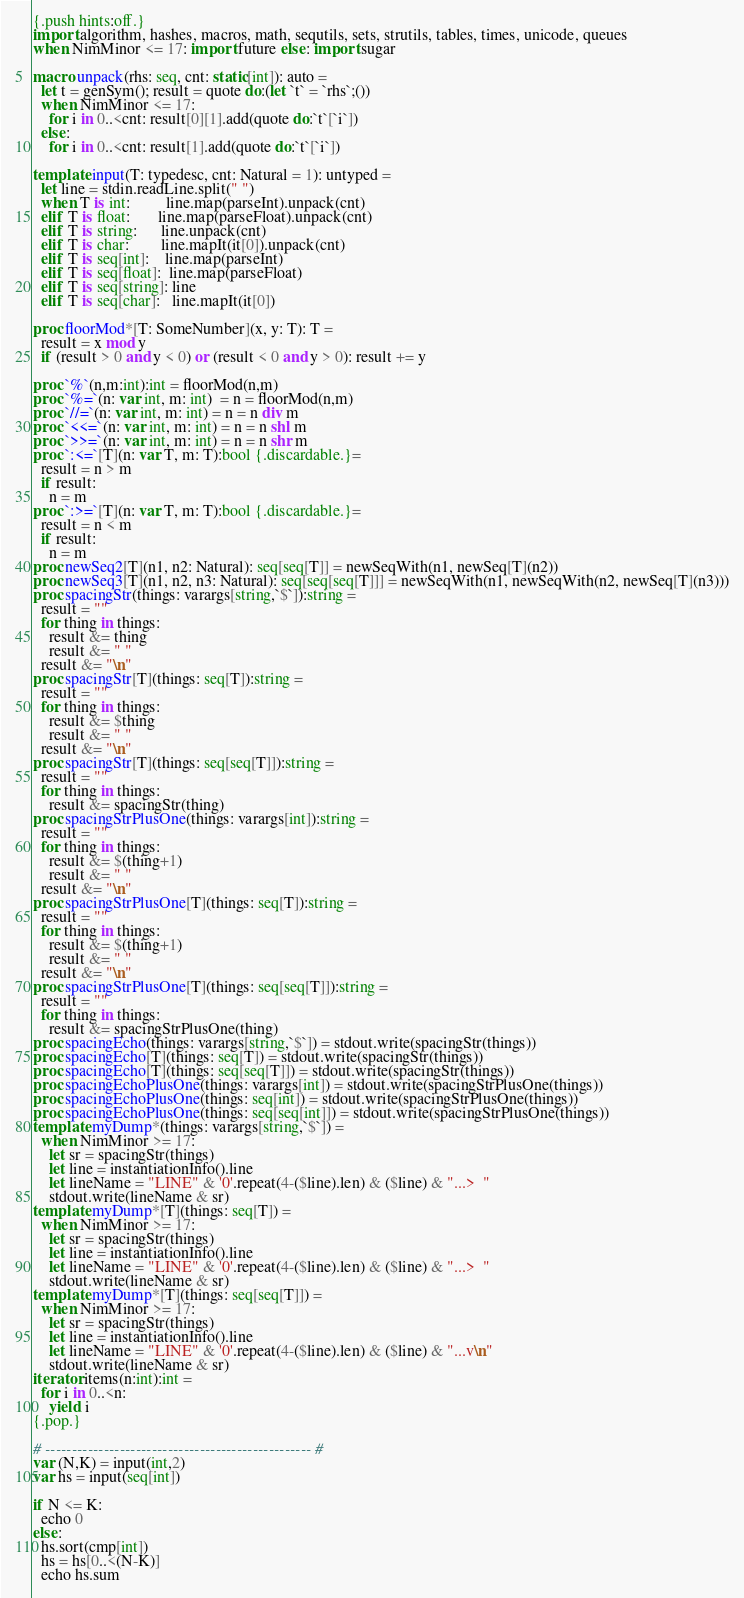Convert code to text. <code><loc_0><loc_0><loc_500><loc_500><_Nim_>{.push hints:off.}
import algorithm, hashes, macros, math, sequtils, sets, strutils, tables, times, unicode, queues
when NimMinor <= 17: import future else: import sugar

macro unpack(rhs: seq, cnt: static[int]): auto =
  let t = genSym(); result = quote do:(let `t` = `rhs`;())
  when NimMinor <= 17:
    for i in 0..<cnt: result[0][1].add(quote do:`t`[`i`])
  else:
    for i in 0..<cnt: result[1].add(quote do:`t`[`i`])
 
template input(T: typedesc, cnt: Natural = 1): untyped =
  let line = stdin.readLine.split(" ")
  when T is int:         line.map(parseInt).unpack(cnt)
  elif T is float:       line.map(parseFloat).unpack(cnt)
  elif T is string:      line.unpack(cnt)
  elif T is char:        line.mapIt(it[0]).unpack(cnt)
  elif T is seq[int]:    line.map(parseInt)
  elif T is seq[float]:  line.map(parseFloat)
  elif T is seq[string]: line
  elif T is seq[char]:   line.mapIt(it[0])

proc floorMod*[T: SomeNumber](x, y: T): T =
  result = x mod y
  if (result > 0 and y < 0) or (result < 0 and y > 0): result += y

proc `%`(n,m:int):int = floorMod(n,m)
proc `%=`(n: var int, m: int)  = n = floorMod(n,m)
proc `//=`(n: var int, m: int) = n = n div m
proc `<<=`(n: var int, m: int) = n = n shl m
proc `>>=`(n: var int, m: int) = n = n shr m
proc `:<=`[T](n: var T, m: T):bool {.discardable.}=
  result = n > m
  if result:
    n = m
proc `:>=`[T](n: var T, m: T):bool {.discardable.}=
  result = n < m
  if result:
    n = m
proc newSeq2[T](n1, n2: Natural): seq[seq[T]] = newSeqWith(n1, newSeq[T](n2))
proc newSeq3[T](n1, n2, n3: Natural): seq[seq[seq[T]]] = newSeqWith(n1, newSeqWith(n2, newSeq[T](n3)))
proc spacingStr(things: varargs[string,`$`]):string =
  result = ""
  for thing in things:
    result &= thing
    result &= " "
  result &= "\n"
proc spacingStr[T](things: seq[T]):string =
  result = ""
  for thing in things:
    result &= $thing
    result &= " "
  result &= "\n"
proc spacingStr[T](things: seq[seq[T]]):string =
  result = ""
  for thing in things:
    result &= spacingStr(thing)
proc spacingStrPlusOne(things: varargs[int]):string =
  result = ""
  for thing in things:
    result &= $(thing+1)
    result &= " "
  result &= "\n"
proc spacingStrPlusOne[T](things: seq[T]):string =
  result = ""
  for thing in things:
    result &= $(thing+1)
    result &= " "
  result &= "\n"
proc spacingStrPlusOne[T](things: seq[seq[T]]):string =
  result = ""
  for thing in things:
    result &= spacingStrPlusOne(thing)
proc spacingEcho(things: varargs[string,`$`]) = stdout.write(spacingStr(things))
proc spacingEcho[T](things: seq[T]) = stdout.write(spacingStr(things))
proc spacingEcho[T](things: seq[seq[T]]) = stdout.write(spacingStr(things))
proc spacingEchoPlusOne(things: varargs[int]) = stdout.write(spacingStrPlusOne(things))
proc spacingEchoPlusOne(things: seq[int]) = stdout.write(spacingStrPlusOne(things))
proc spacingEchoPlusOne(things: seq[seq[int]]) = stdout.write(spacingStrPlusOne(things))
template myDump*(things: varargs[string,`$`]) =
  when NimMinor >= 17:
    let sr = spacingStr(things)
    let line = instantiationInfo().line
    let lineName = "LINE" & '0'.repeat(4-($line).len) & ($line) & "...>  "
    stdout.write(lineName & sr)
template myDump*[T](things: seq[T]) =
  when NimMinor >= 17:
    let sr = spacingStr(things)
    let line = instantiationInfo().line
    let lineName = "LINE" & '0'.repeat(4-($line).len) & ($line) & "...>  "
    stdout.write(lineName & sr)
template myDump*[T](things: seq[seq[T]]) =
  when NimMinor >= 17:
    let sr = spacingStr(things)
    let line = instantiationInfo().line
    let lineName = "LINE" & '0'.repeat(4-($line).len) & ($line) & "...v\n"
    stdout.write(lineName & sr)
iterator items(n:int):int = 
  for i in 0..<n:
    yield i
{.pop.}

# -------------------------------------------------- #
var (N,K) = input(int,2)
var hs = input(seq[int])

if N <= K:
  echo 0
else:
  hs.sort(cmp[int])
  hs = hs[0..<(N-K)]
  echo hs.sum</code> 